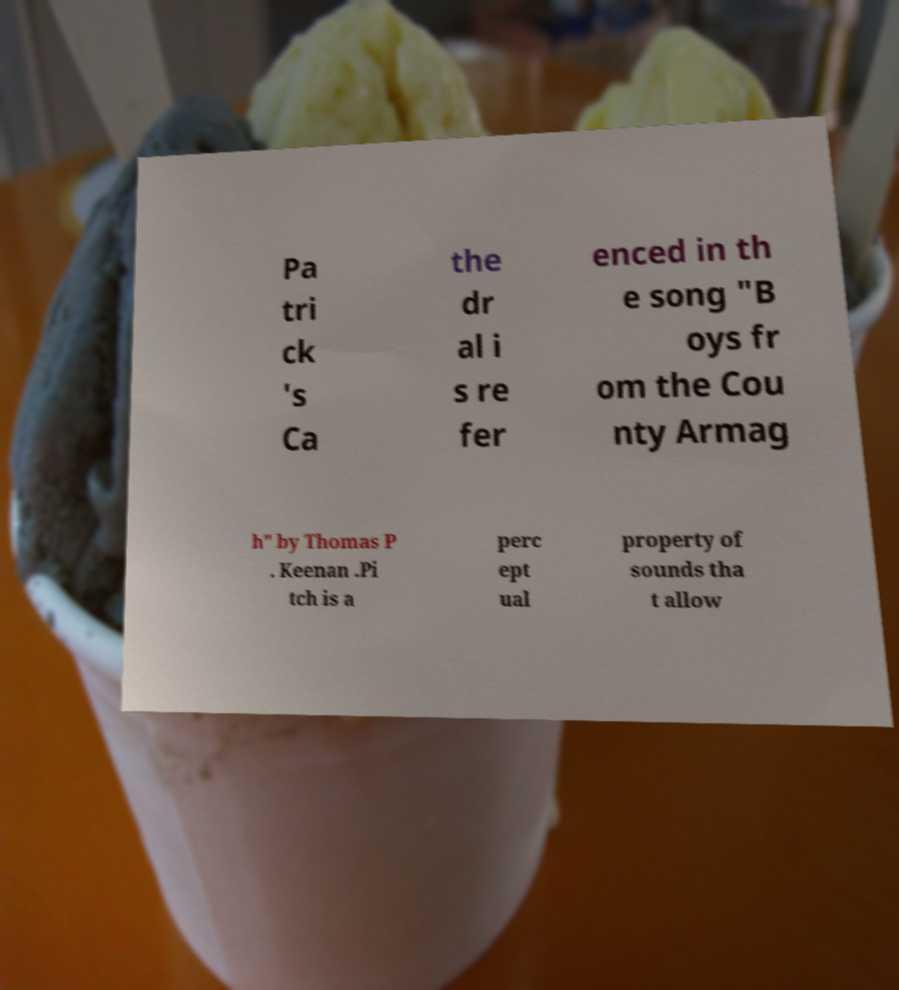For documentation purposes, I need the text within this image transcribed. Could you provide that? Pa tri ck 's Ca the dr al i s re fer enced in th e song "B oys fr om the Cou nty Armag h" by Thomas P . Keenan .Pi tch is a perc ept ual property of sounds tha t allow 